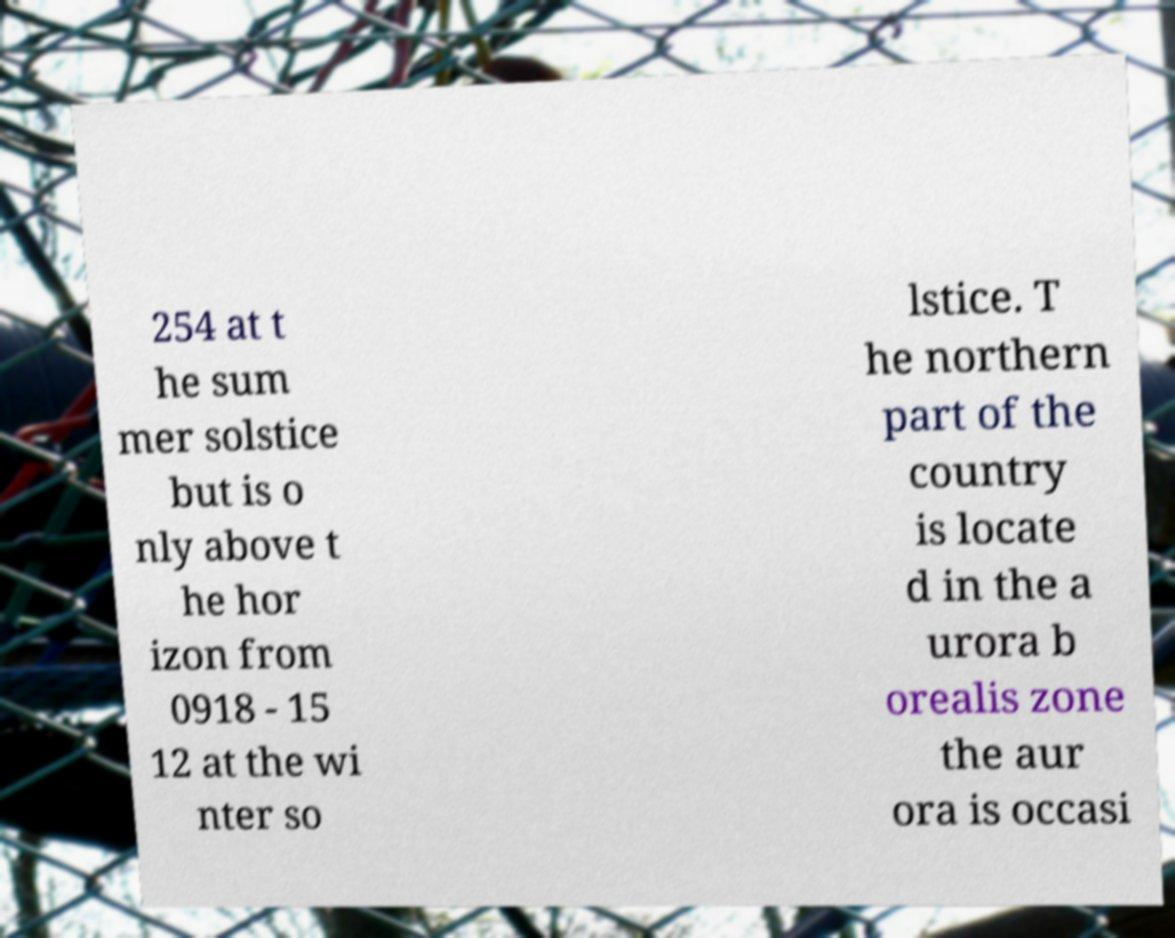I need the written content from this picture converted into text. Can you do that? 254 at t he sum mer solstice but is o nly above t he hor izon from 0918 - 15 12 at the wi nter so lstice. T he northern part of the country is locate d in the a urora b orealis zone the aur ora is occasi 